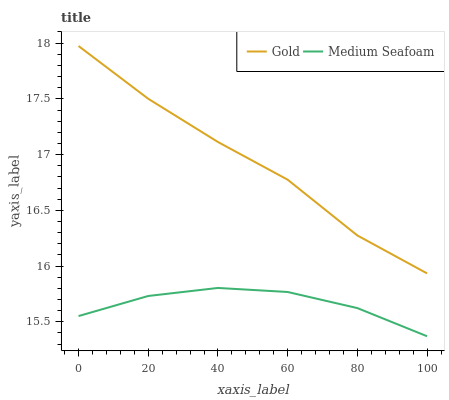Does Medium Seafoam have the minimum area under the curve?
Answer yes or no. Yes. Does Gold have the maximum area under the curve?
Answer yes or no. Yes. Does Gold have the minimum area under the curve?
Answer yes or no. No. Is Medium Seafoam the smoothest?
Answer yes or no. Yes. Is Gold the roughest?
Answer yes or no. Yes. Is Gold the smoothest?
Answer yes or no. No. Does Medium Seafoam have the lowest value?
Answer yes or no. Yes. Does Gold have the lowest value?
Answer yes or no. No. Does Gold have the highest value?
Answer yes or no. Yes. Is Medium Seafoam less than Gold?
Answer yes or no. Yes. Is Gold greater than Medium Seafoam?
Answer yes or no. Yes. Does Medium Seafoam intersect Gold?
Answer yes or no. No. 